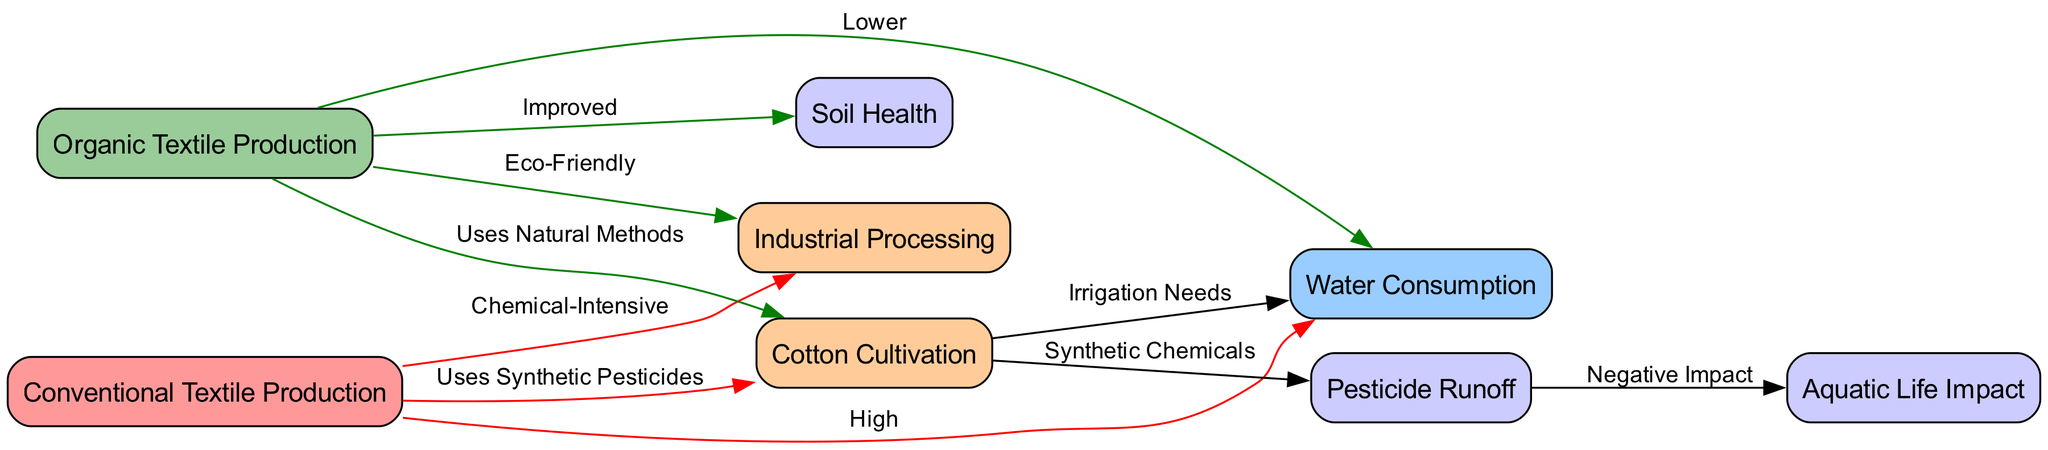What is the relationship between conventional textile production and water consumption? The diagram shows that the edge connecting "conventional textile production" to "water consumption" is labeled "High," indicating a significant amount of water is used in this process.
Answer: High How many nodes are present in the diagram? Counting the unique entities, we identify eight nodes in total, which are: conventional textile production, organic textile production, water consumption, cotton cultivation, industrial processing, pesticide runoff, soil health, and aquatic life impact.
Answer: Eight What type of pesticides are used in conventional textile production? The edge from "conventional textile production" to "cotton cultivation" specifies that it "Uses Synthetic Pesticides," which indicates the type of pesticide employed in this production method.
Answer: Synthetic Pesticides What is the label for the edge connecting organic textile production to water consumption? The edge reflects that organic textile production consumes a "Lower" amount of water, explained by its use of more sustainable practices.
Answer: Lower How do organic textile production methods impact soil health? The edge leading from "organic textile production" to "soil health" is labeled "Improved," suggesting that these practices enhance the quality of the soil compared to conventional methods.
Answer: Improved What is the impact of pesticide runoff on aquatic life? The diagram clearly indicates through the edge from "pesticide runoff" to "aquatic life impact" that it has a "Negative Impact," showing the detrimental effect of chemicals on aquatic ecosystems.
Answer: Negative Impact Which production method is chemically intensive? The label on the edge from "conventional textile production" to "industrial processing" states "Chemical-Intensive," meaning this method involves a high use of chemicals in the production process.
Answer: Chemical-Intensive What is the relationship between organic textile production and industrial processing? The edge indicates that organic textile production results in "Eco-Friendly" industrial processing, highlighting its environmentally conscious approach.
Answer: Eco-Friendly What does cotton cultivation affect in terms of water usage? The edge from "cotton cultivation" to "water consumption" is labeled "Irrigation Needs," which connects the cultivation of cotton directly to its water usage requirements.
Answer: Irrigation Needs 